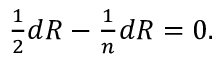<formula> <loc_0><loc_0><loc_500><loc_500>\frac { 1 } { 2 } d R - { \frac { 1 } { n } } d R = 0 .</formula> 